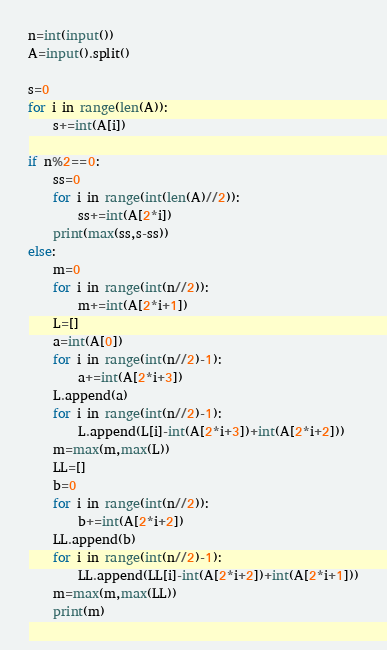<code> <loc_0><loc_0><loc_500><loc_500><_Python_>n=int(input())
A=input().split()

s=0
for i in range(len(A)):
    s+=int(A[i])

if n%2==0:
    ss=0
    for i in range(int(len(A)//2)):
        ss+=int(A[2*i])
    print(max(ss,s-ss))
else:
    m=0
    for i in range(int(n//2)):
        m+=int(A[2*i+1])
    L=[]
    a=int(A[0])
    for i in range(int(n//2)-1):
        a+=int(A[2*i+3])
    L.append(a)
    for i in range(int(n//2)-1):
        L.append(L[i]-int(A[2*i+3])+int(A[2*i+2]))
    m=max(m,max(L))
    LL=[]
    b=0
    for i in range(int(n//2)):
        b+=int(A[2*i+2])
    LL.append(b)
    for i in range(int(n//2)-1):
        LL.append(LL[i]-int(A[2*i+2])+int(A[2*i+1]))
    m=max(m,max(LL))
    print(m)
</code> 